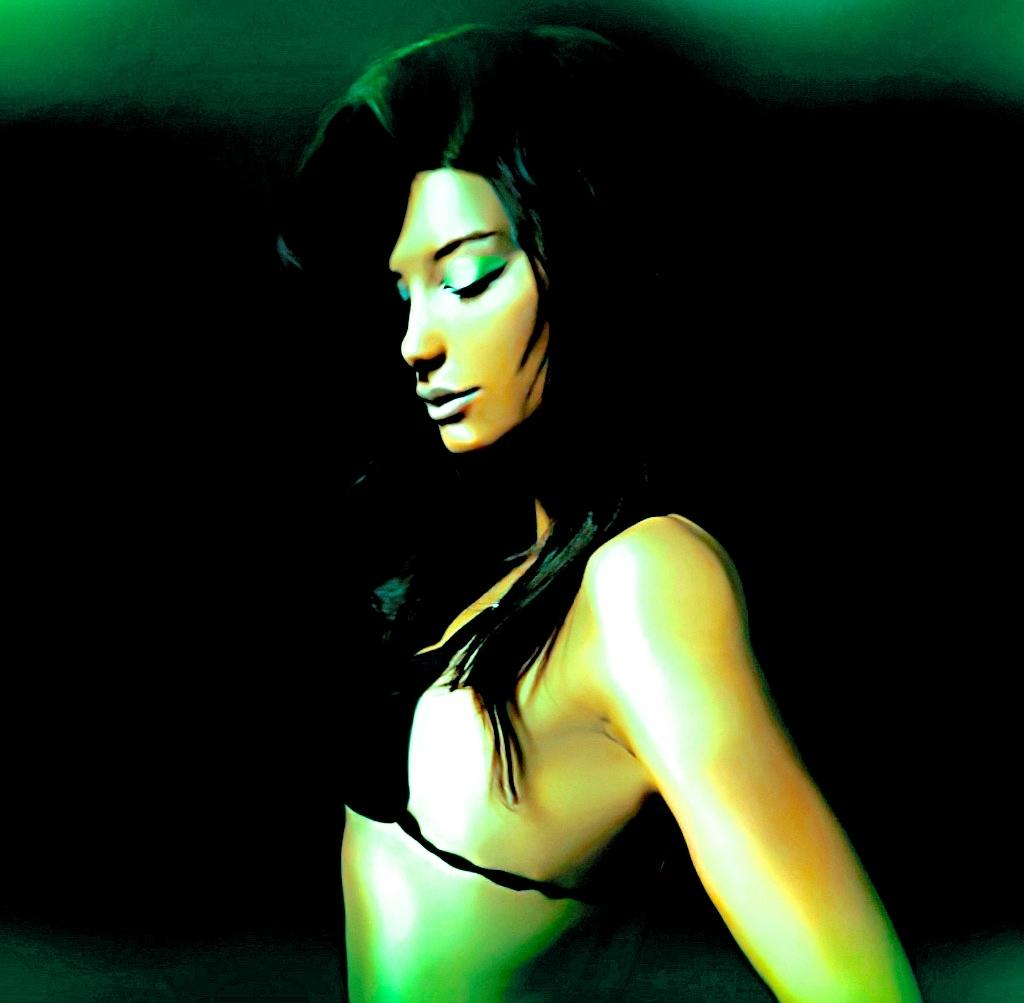What is the main subject of the image? There is a picture of a woman. What can be observed about the background of the image? The background of the image is dark. How many roses are present in the image? There are no roses visible in the image; it features a picture of a woman with a dark background. What part of the woman's body is missing in the image? There is no indication that any part of the woman's body is missing in the image. 